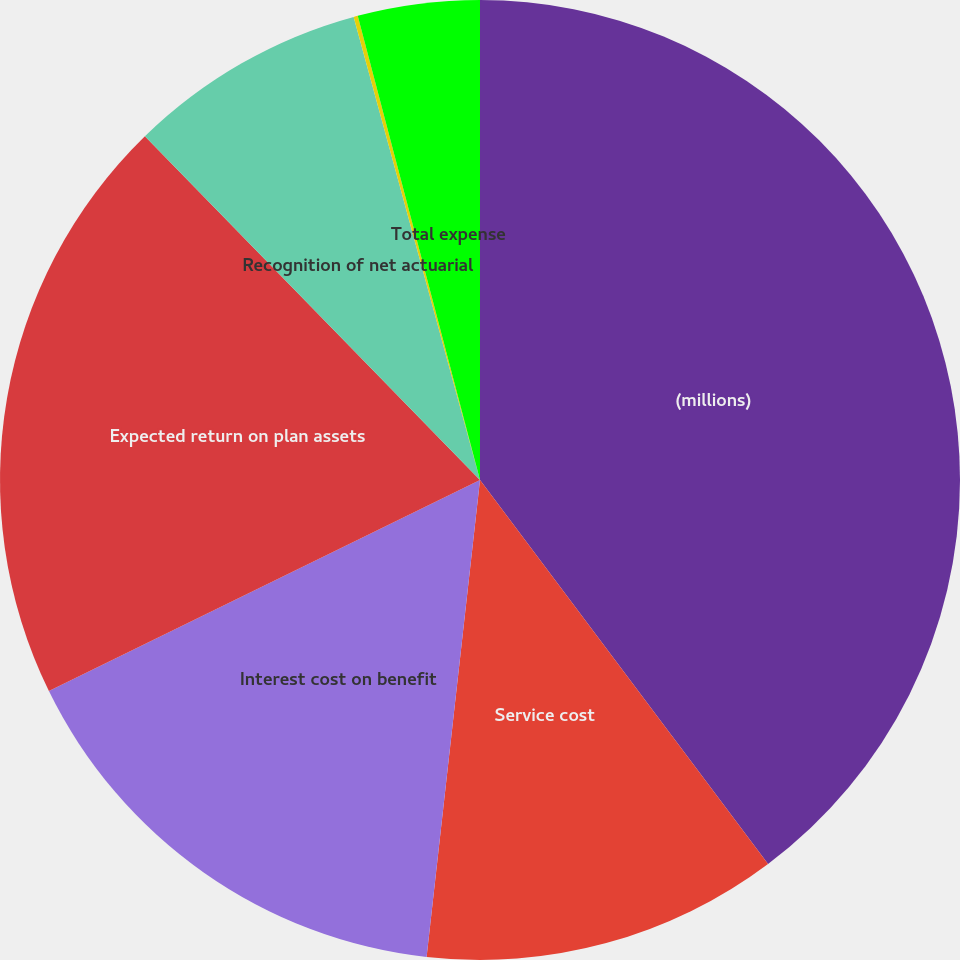<chart> <loc_0><loc_0><loc_500><loc_500><pie_chart><fcel>(millions)<fcel>Service cost<fcel>Interest cost on benefit<fcel>Expected return on plan assets<fcel>Recognition of net actuarial<fcel>Amortization of prior service<fcel>Total expense<nl><fcel>39.76%<fcel>12.02%<fcel>15.98%<fcel>19.95%<fcel>8.06%<fcel>0.14%<fcel>4.1%<nl></chart> 